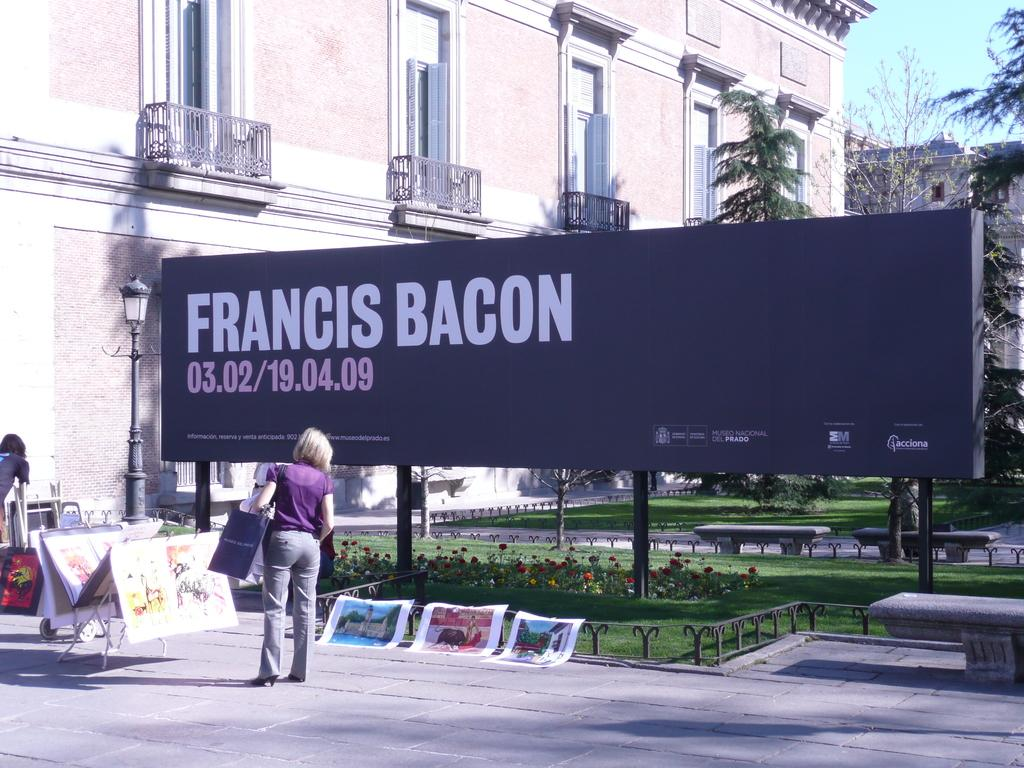<image>
Write a terse but informative summary of the picture. A memorial for Francis Bacon has some flowers planted near the benches. 